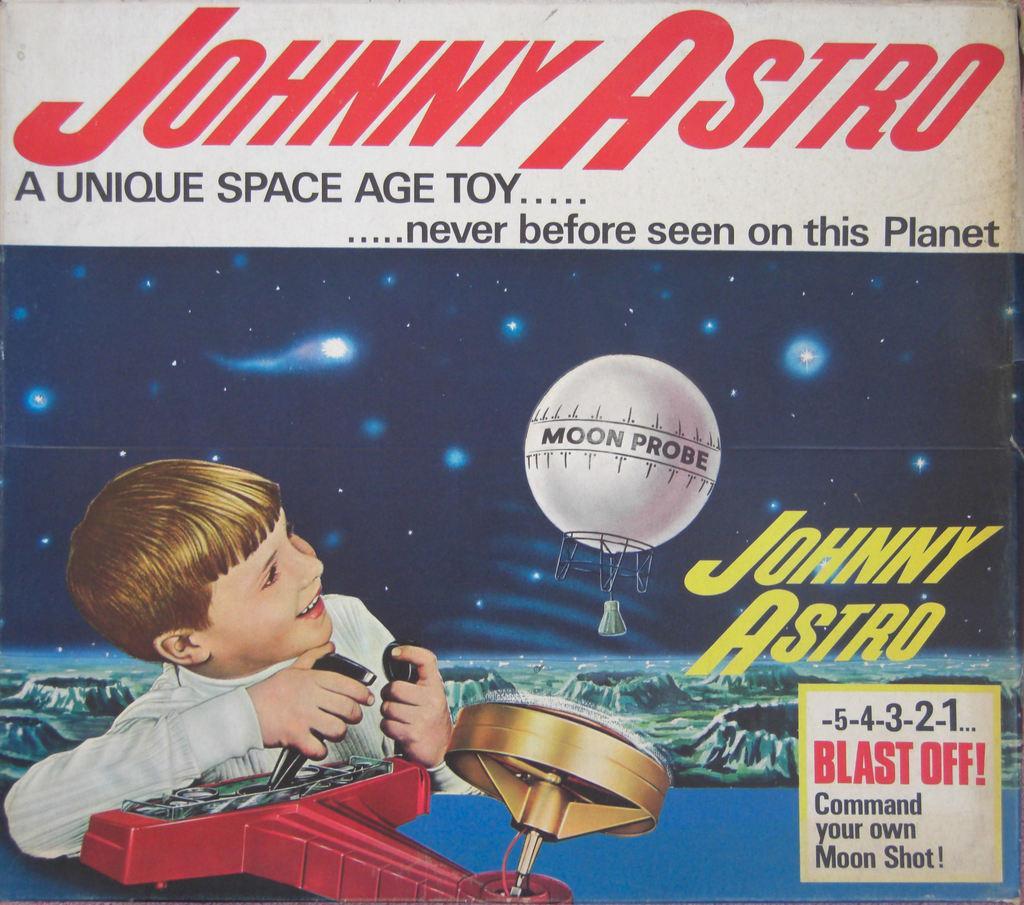Could you give a brief overview of what you see in this image? It is a poster. In this poster, we can see kid, some text, few objects, stars. 